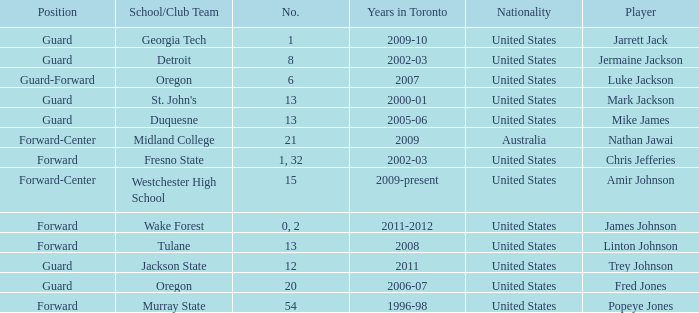What school/club team is Amir Johnson on? Westchester High School. 